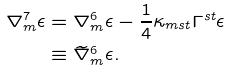<formula> <loc_0><loc_0><loc_500><loc_500>\nabla ^ { 7 } _ { m } \epsilon & = \nabla ^ { 6 } _ { m } \epsilon - \frac { 1 } { 4 } \kappa _ { m s t } \Gamma ^ { s t } \epsilon \\ & \equiv \widetilde { \nabla } ^ { 6 } _ { m } \epsilon .</formula> 